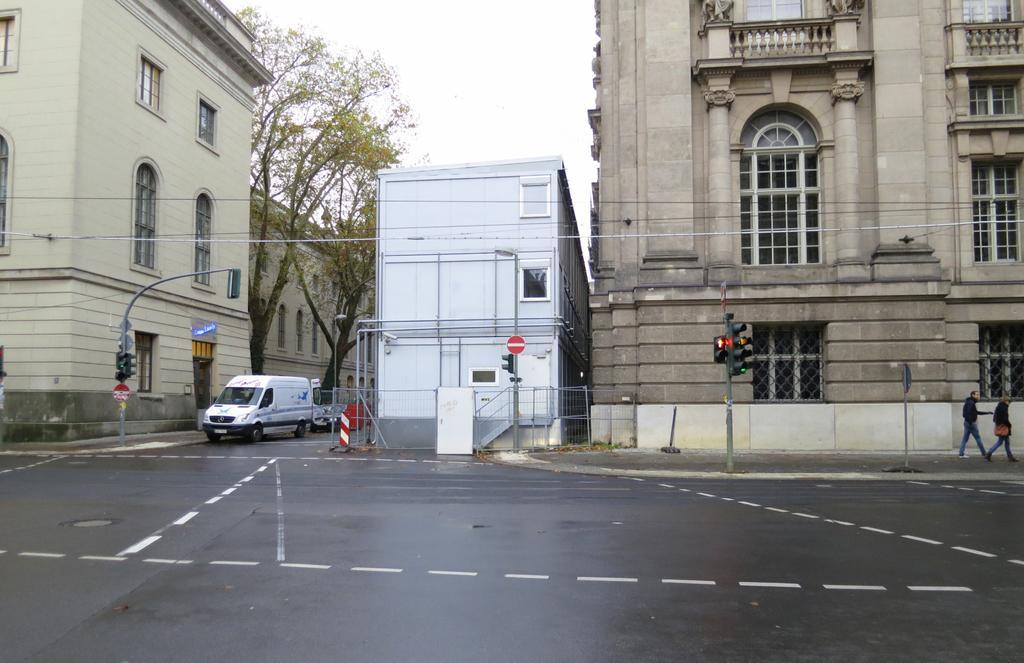Please provide a concise description of this image. In the center of the image there are buildings. There is a road on which there are vehicles. There is a traffic signal. There are trees. In the background of the image there is sky. 